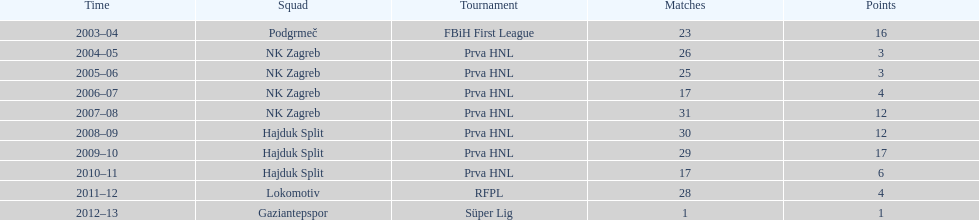What is senijad ibricic's record for the most goals scored during one season? 35. 